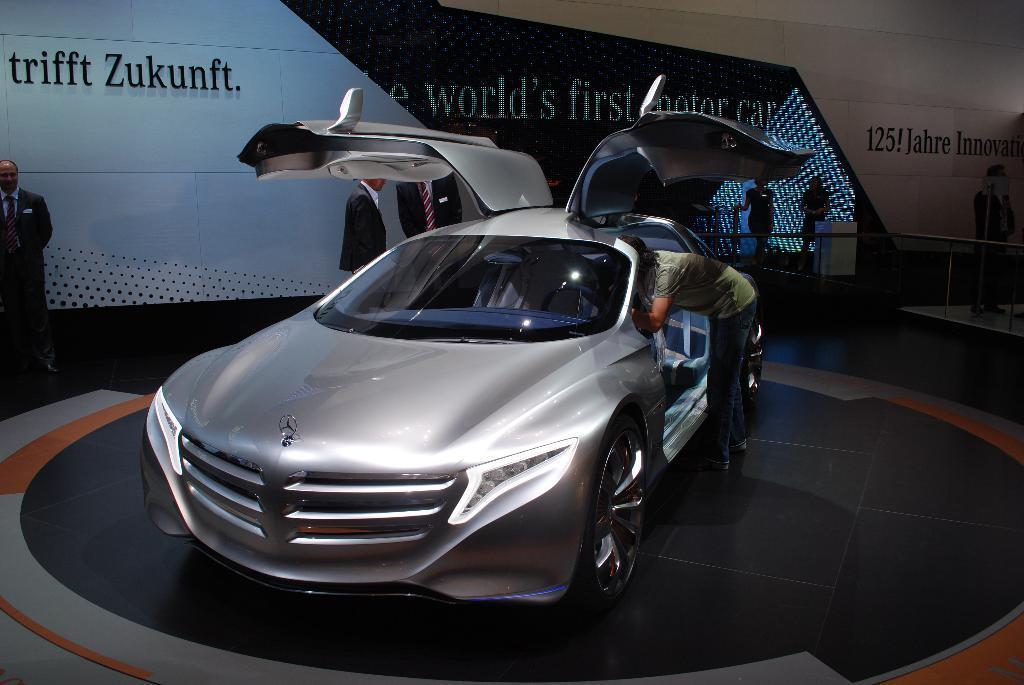How would you summarize this image in a sentence or two? In this image there are group of persons standing. In the front there is a car in the center. On the left side there is a man standing and on the right side there are persons standing. In the background there is a banner with some text written on it. In the front on the right side of the car there is a man standing. 